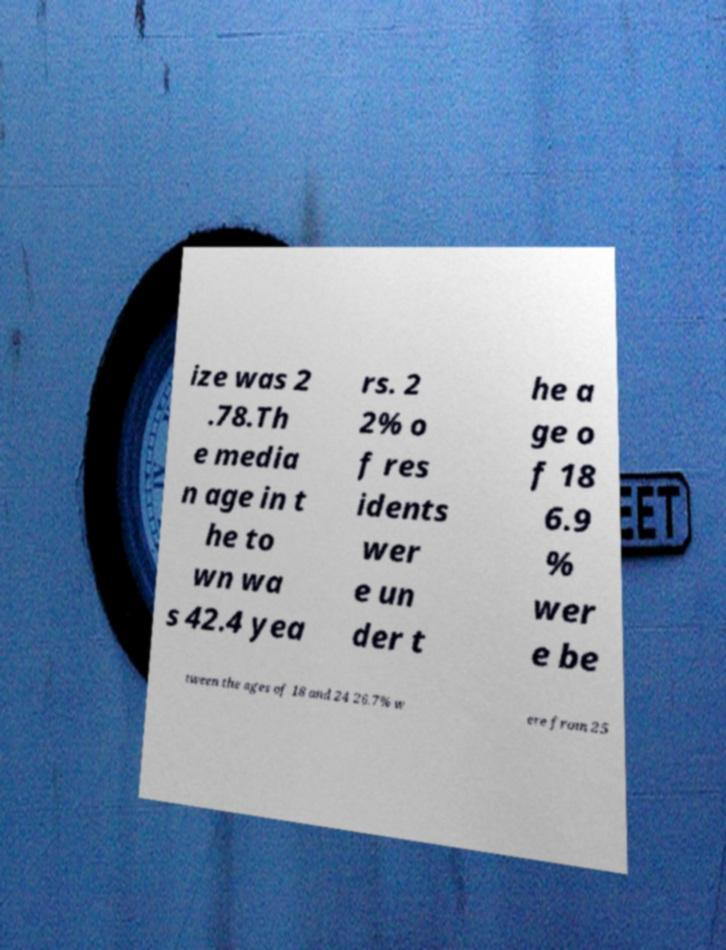I need the written content from this picture converted into text. Can you do that? ize was 2 .78.Th e media n age in t he to wn wa s 42.4 yea rs. 2 2% o f res idents wer e un der t he a ge o f 18 6.9 % wer e be tween the ages of 18 and 24 26.7% w ere from 25 